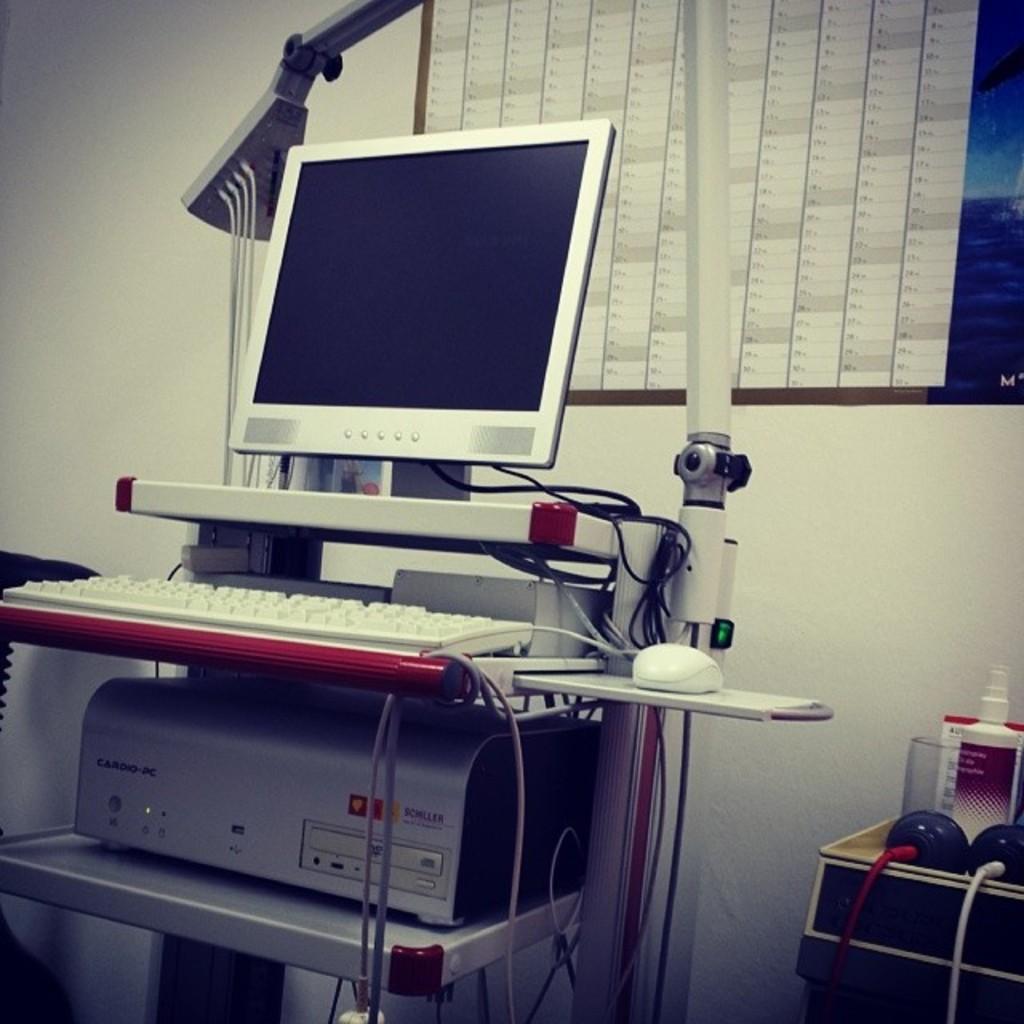Please provide a concise description of this image. In this image we can see the monitor and other electronic devices. In the background, we can see a window and the wall. And on the right, we can see some objects. 